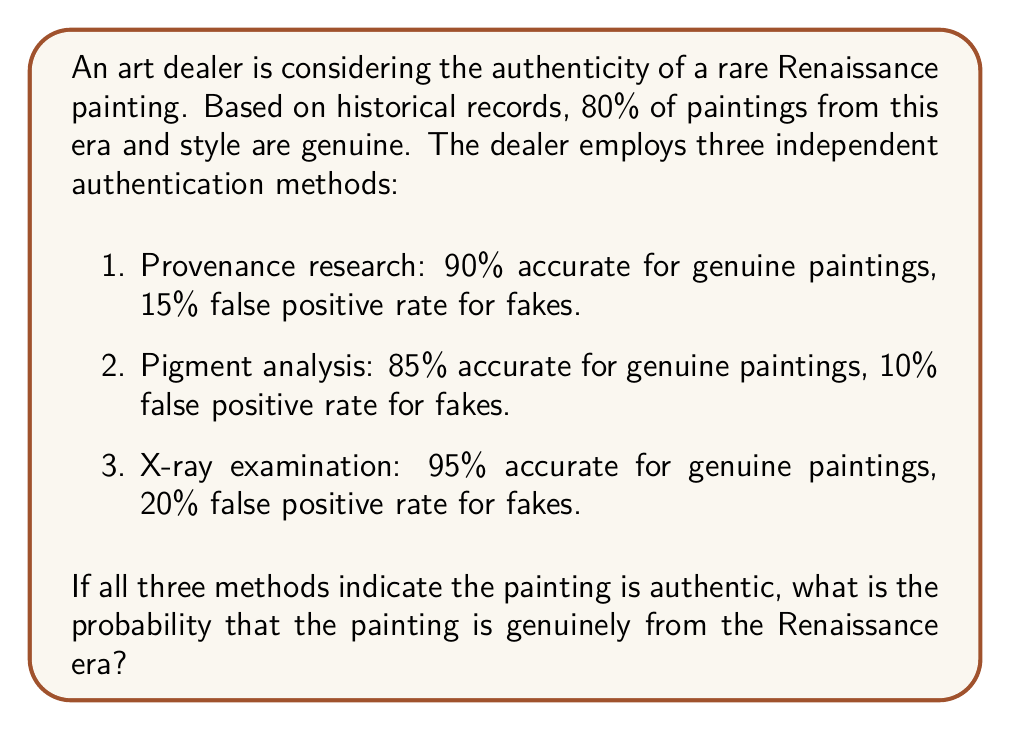Solve this math problem. Let's approach this problem using Bayes' theorem and the given information:

1. Let A be the event that the painting is authentic.
2. Let B be the event that all three tests indicate authenticity.

We need to find P(A|B), which is the probability the painting is authentic given all tests are positive.

Given:
- P(A) = 0.80 (prior probability of authenticity)
- P(B|A) = 0.90 * 0.85 * 0.95 = 0.72675 (probability all tests are positive given the painting is authentic)
- P(B|not A) = 0.15 * 0.10 * 0.20 = 0.003 (probability all tests are positive given the painting is not authentic)

Using Bayes' theorem:

$$ P(A|B) = \frac{P(B|A) \cdot P(A)}{P(B|A) \cdot P(A) + P(B|\text{not }A) \cdot P(\text{not }A)} $$

Substituting the values:

$$ P(A|B) = \frac{0.72675 \cdot 0.80}{0.72675 \cdot 0.80 + 0.003 \cdot 0.20} $$

$$ P(A|B) = \frac{0.5814}{0.5814 + 0.0006} = \frac{0.5814}{0.582} $$

$$ P(A|B) \approx 0.9989 $$

Therefore, the probability that the painting is genuine, given all three tests indicate authenticity, is approximately 0.9989 or 99.89%.
Answer: The probability that the painting is genuinely from the Renaissance era, given that all three authentication methods indicate it is authentic, is approximately 0.9989 or 99.89%. 